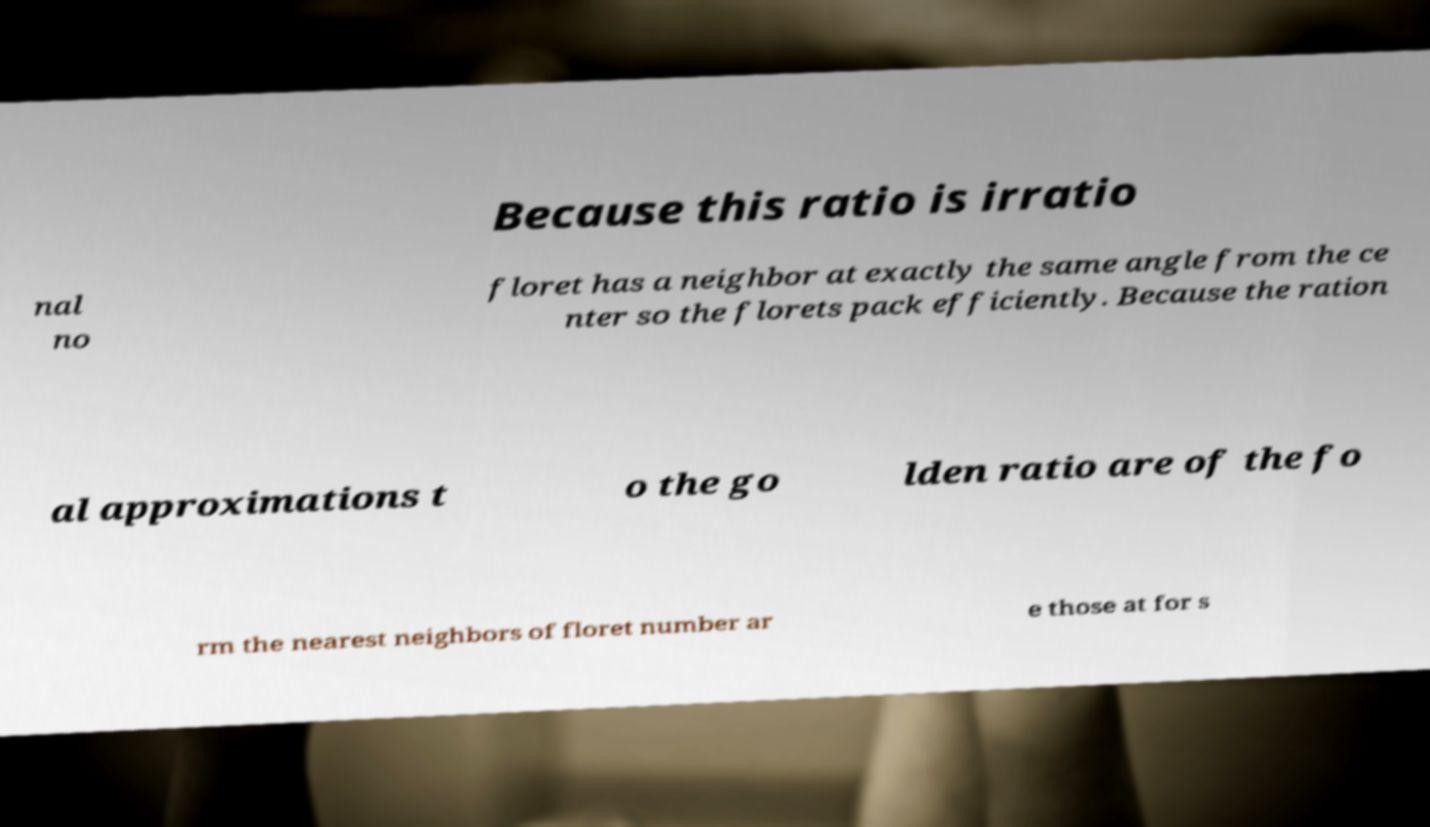Could you assist in decoding the text presented in this image and type it out clearly? Because this ratio is irratio nal no floret has a neighbor at exactly the same angle from the ce nter so the florets pack efficiently. Because the ration al approximations t o the go lden ratio are of the fo rm the nearest neighbors of floret number ar e those at for s 